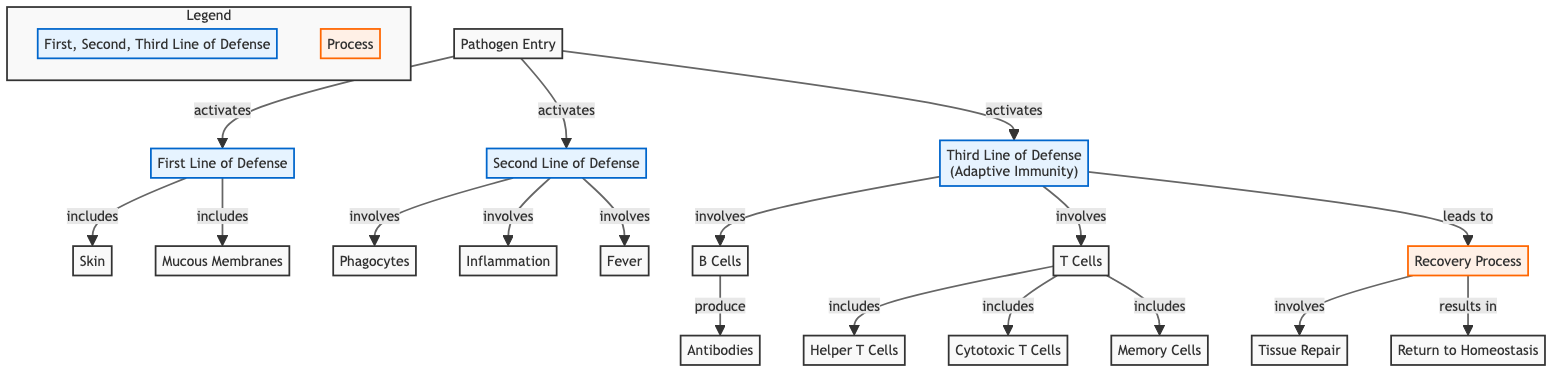What activates the first line of defense? The diagram shows that the "Pathogen Entry" activates the "First Line of Defense". This is illustrated by the arrow connecting these two nodes, signifying that the presence of a pathogen triggers this initial response.
Answer: Pathogen Entry How many lines of defense are represented in the diagram? There are three lines of defense represented in the diagram: the First Line of Defense, Second Line of Defense, and Third Line of Defense. This can be counted from the distinct labeled sections in the diagram.
Answer: 3 Which type of immune cells are involved in producing antibodies? The diagram indicates that "B Cells" are responsible for producing antibodies, as shown by the arrow leading from the "B Cells" node to the "Antibodies" node.
Answer: B Cells What process follows the activation of the third line of defense? According to the diagram, after the Third Line of Defense is activated, it leads to the "Recovery Process". This relationship is depicted by an arrow connecting these two nodes.
Answer: Recovery Process What is the result of the recovery process? The diagram states that the "Recovery Process" results in the "Return to Homeostasis". This is shown by the arrow leading from "Recovery Process" to "Return to Homeostasis".
Answer: Return to Homeostasis What are the components of the second line of defense? The diagram includes two components of the Second Line of Defense: "Phagocytes" and "Inflammation". Both of these are listed under the "Second Line of Defense" section in the diagram.
Answer: Phagocytes, Inflammation Which cells are classified as "Helper T Cells" in the diagram? The diagram identifies "Helper T Cells" as a subgroup of "T Cells". The connection is illustrated by the arrow linking "T Cells" to the node "Helper T Cells".
Answer: Helper T Cells What is the purpose of mucous membranes in the immune response? The diagram places "Mucous Membranes" under the "First Line of Defense", indicating that their purpose is part of the initial barrier against pathogens, serving to trap and expel invaders.
Answer: First Line of Defense Which line of defense does inflammation belong to? Inflammation is labeled under the "Second Line of Defense" in the diagram, as indicated by its direct connection to the Second Line of Defense node.
Answer: Second Line of Defense 